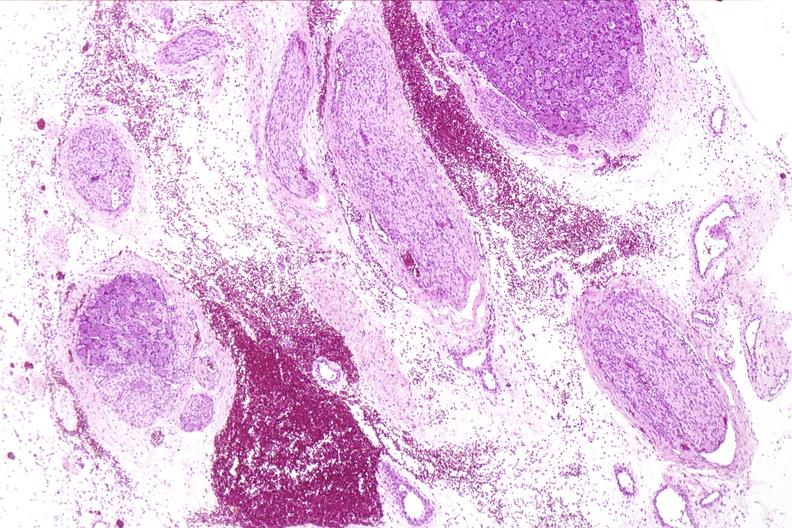what is present?
Answer the question using a single word or phrase. Nervous 